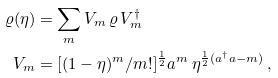Convert formula to latex. <formula><loc_0><loc_0><loc_500><loc_500>\varrho ( \eta ) & = \sum _ { m } V _ { m } \, \varrho \, V _ { m } ^ { \dag } \\ V _ { m } & = [ ( 1 - \eta ) ^ { m } / m ! ] ^ { \frac { 1 } { 2 } } a ^ { m } \, \eta ^ { \frac { 1 } { 2 } ( a ^ { \dag } a - m ) } \, ,</formula> 